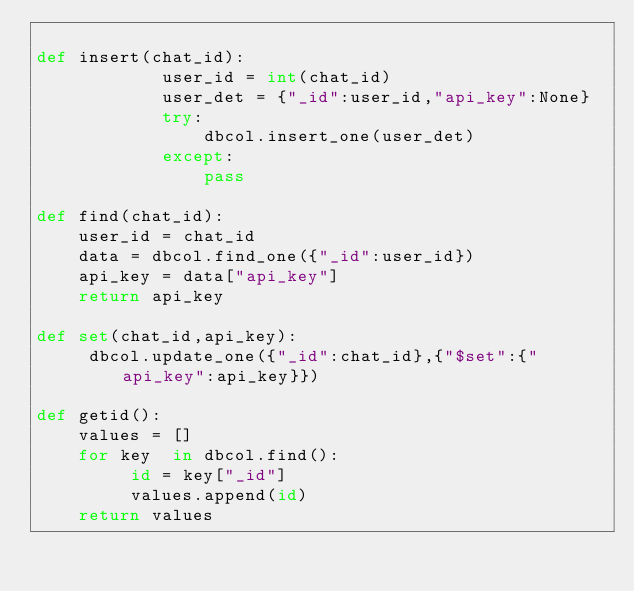Convert code to text. <code><loc_0><loc_0><loc_500><loc_500><_Python_>
def insert(chat_id):
            user_id = int(chat_id)
            user_det = {"_id":user_id,"api_key":None}
            try:
            	dbcol.insert_one(user_det)
            except:
            	pass

def find(chat_id):
	user_id = chat_id
	data = dbcol.find_one({"_id":user_id})
	api_key = data["api_key"]
	return api_key

def set(chat_id,api_key):
	 dbcol.update_one({"_id":chat_id},{"$set":{"api_key":api_key}})

def getid():
    values = []
    for key  in dbcol.find():
         id = key["_id"]
         values.append(id) 
    return values
</code> 